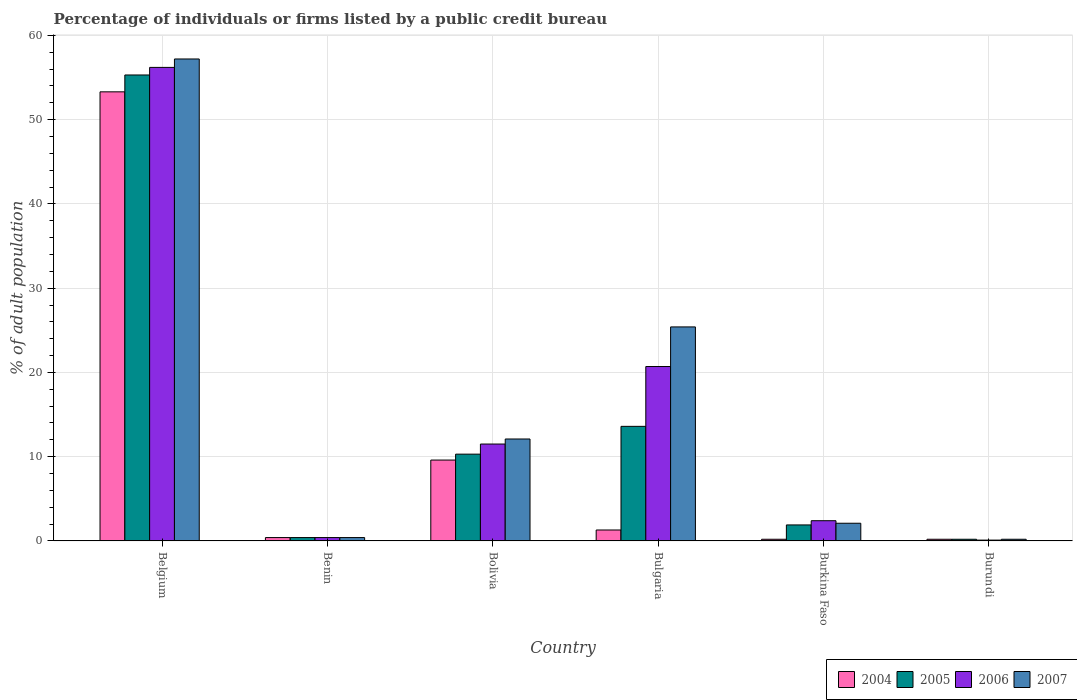How many groups of bars are there?
Offer a very short reply. 6. Are the number of bars on each tick of the X-axis equal?
Your answer should be compact. Yes. What is the label of the 2nd group of bars from the left?
Provide a succinct answer. Benin. Across all countries, what is the maximum percentage of population listed by a public credit bureau in 2004?
Your response must be concise. 53.3. In which country was the percentage of population listed by a public credit bureau in 2005 maximum?
Make the answer very short. Belgium. In which country was the percentage of population listed by a public credit bureau in 2005 minimum?
Ensure brevity in your answer.  Burundi. What is the total percentage of population listed by a public credit bureau in 2005 in the graph?
Your response must be concise. 81.7. What is the difference between the percentage of population listed by a public credit bureau in 2005 in Bulgaria and the percentage of population listed by a public credit bureau in 2006 in Bolivia?
Provide a succinct answer. 2.1. What is the average percentage of population listed by a public credit bureau in 2004 per country?
Keep it short and to the point. 10.83. What is the difference between the percentage of population listed by a public credit bureau of/in 2005 and percentage of population listed by a public credit bureau of/in 2007 in Bulgaria?
Your answer should be very brief. -11.8. In how many countries, is the percentage of population listed by a public credit bureau in 2005 greater than 4 %?
Your answer should be compact. 3. What is the ratio of the percentage of population listed by a public credit bureau in 2005 in Belgium to that in Bolivia?
Provide a succinct answer. 5.37. Is the percentage of population listed by a public credit bureau in 2004 in Burkina Faso less than that in Burundi?
Provide a short and direct response. No. Is the difference between the percentage of population listed by a public credit bureau in 2005 in Bolivia and Burkina Faso greater than the difference between the percentage of population listed by a public credit bureau in 2007 in Bolivia and Burkina Faso?
Offer a very short reply. No. What is the difference between the highest and the second highest percentage of population listed by a public credit bureau in 2005?
Offer a terse response. -3.3. What is the difference between the highest and the lowest percentage of population listed by a public credit bureau in 2006?
Your answer should be very brief. 56.1. In how many countries, is the percentage of population listed by a public credit bureau in 2004 greater than the average percentage of population listed by a public credit bureau in 2004 taken over all countries?
Make the answer very short. 1. Is the sum of the percentage of population listed by a public credit bureau in 2005 in Burkina Faso and Burundi greater than the maximum percentage of population listed by a public credit bureau in 2006 across all countries?
Keep it short and to the point. No. What does the 4th bar from the left in Burkina Faso represents?
Offer a very short reply. 2007. Is it the case that in every country, the sum of the percentage of population listed by a public credit bureau in 2006 and percentage of population listed by a public credit bureau in 2005 is greater than the percentage of population listed by a public credit bureau in 2007?
Make the answer very short. Yes. Are all the bars in the graph horizontal?
Make the answer very short. No. How many countries are there in the graph?
Provide a succinct answer. 6. What is the difference between two consecutive major ticks on the Y-axis?
Your answer should be compact. 10. Are the values on the major ticks of Y-axis written in scientific E-notation?
Ensure brevity in your answer.  No. Does the graph contain any zero values?
Ensure brevity in your answer.  No. What is the title of the graph?
Provide a succinct answer. Percentage of individuals or firms listed by a public credit bureau. Does "1979" appear as one of the legend labels in the graph?
Keep it short and to the point. No. What is the label or title of the Y-axis?
Your answer should be compact. % of adult population. What is the % of adult population of 2004 in Belgium?
Your answer should be very brief. 53.3. What is the % of adult population in 2005 in Belgium?
Offer a terse response. 55.3. What is the % of adult population of 2006 in Belgium?
Offer a terse response. 56.2. What is the % of adult population of 2007 in Belgium?
Provide a succinct answer. 57.2. What is the % of adult population of 2007 in Benin?
Offer a terse response. 0.4. What is the % of adult population of 2004 in Bolivia?
Your answer should be very brief. 9.6. What is the % of adult population of 2007 in Bolivia?
Your answer should be compact. 12.1. What is the % of adult population in 2006 in Bulgaria?
Your answer should be very brief. 20.7. What is the % of adult population in 2007 in Bulgaria?
Your answer should be very brief. 25.4. What is the % of adult population in 2006 in Burkina Faso?
Your answer should be compact. 2.4. What is the % of adult population in 2007 in Burkina Faso?
Offer a very short reply. 2.1. What is the % of adult population in 2004 in Burundi?
Your answer should be compact. 0.2. What is the % of adult population in 2006 in Burundi?
Provide a short and direct response. 0.1. Across all countries, what is the maximum % of adult population of 2004?
Give a very brief answer. 53.3. Across all countries, what is the maximum % of adult population in 2005?
Offer a very short reply. 55.3. Across all countries, what is the maximum % of adult population of 2006?
Offer a terse response. 56.2. Across all countries, what is the maximum % of adult population of 2007?
Provide a succinct answer. 57.2. Across all countries, what is the minimum % of adult population of 2004?
Make the answer very short. 0.2. What is the total % of adult population in 2004 in the graph?
Offer a terse response. 65. What is the total % of adult population of 2005 in the graph?
Your answer should be very brief. 81.7. What is the total % of adult population in 2006 in the graph?
Offer a very short reply. 91.3. What is the total % of adult population of 2007 in the graph?
Your answer should be compact. 97.4. What is the difference between the % of adult population of 2004 in Belgium and that in Benin?
Give a very brief answer. 52.9. What is the difference between the % of adult population of 2005 in Belgium and that in Benin?
Offer a terse response. 54.9. What is the difference between the % of adult population of 2006 in Belgium and that in Benin?
Give a very brief answer. 55.8. What is the difference between the % of adult population of 2007 in Belgium and that in Benin?
Provide a succinct answer. 56.8. What is the difference between the % of adult population of 2004 in Belgium and that in Bolivia?
Your answer should be very brief. 43.7. What is the difference between the % of adult population in 2006 in Belgium and that in Bolivia?
Give a very brief answer. 44.7. What is the difference between the % of adult population in 2007 in Belgium and that in Bolivia?
Give a very brief answer. 45.1. What is the difference between the % of adult population of 2004 in Belgium and that in Bulgaria?
Offer a terse response. 52. What is the difference between the % of adult population of 2005 in Belgium and that in Bulgaria?
Give a very brief answer. 41.7. What is the difference between the % of adult population of 2006 in Belgium and that in Bulgaria?
Provide a short and direct response. 35.5. What is the difference between the % of adult population of 2007 in Belgium and that in Bulgaria?
Your response must be concise. 31.8. What is the difference between the % of adult population of 2004 in Belgium and that in Burkina Faso?
Your answer should be compact. 53.1. What is the difference between the % of adult population in 2005 in Belgium and that in Burkina Faso?
Your answer should be compact. 53.4. What is the difference between the % of adult population of 2006 in Belgium and that in Burkina Faso?
Your answer should be very brief. 53.8. What is the difference between the % of adult population in 2007 in Belgium and that in Burkina Faso?
Your answer should be compact. 55.1. What is the difference between the % of adult population of 2004 in Belgium and that in Burundi?
Offer a terse response. 53.1. What is the difference between the % of adult population of 2005 in Belgium and that in Burundi?
Ensure brevity in your answer.  55.1. What is the difference between the % of adult population in 2006 in Belgium and that in Burundi?
Provide a succinct answer. 56.1. What is the difference between the % of adult population of 2007 in Belgium and that in Burundi?
Give a very brief answer. 57. What is the difference between the % of adult population in 2004 in Benin and that in Bolivia?
Provide a succinct answer. -9.2. What is the difference between the % of adult population of 2005 in Benin and that in Bolivia?
Your response must be concise. -9.9. What is the difference between the % of adult population of 2007 in Benin and that in Bolivia?
Offer a very short reply. -11.7. What is the difference between the % of adult population of 2004 in Benin and that in Bulgaria?
Provide a short and direct response. -0.9. What is the difference between the % of adult population of 2005 in Benin and that in Bulgaria?
Provide a succinct answer. -13.2. What is the difference between the % of adult population in 2006 in Benin and that in Bulgaria?
Make the answer very short. -20.3. What is the difference between the % of adult population of 2007 in Benin and that in Bulgaria?
Offer a very short reply. -25. What is the difference between the % of adult population in 2004 in Benin and that in Burkina Faso?
Ensure brevity in your answer.  0.2. What is the difference between the % of adult population in 2006 in Benin and that in Burkina Faso?
Provide a short and direct response. -2. What is the difference between the % of adult population in 2007 in Benin and that in Burkina Faso?
Your response must be concise. -1.7. What is the difference between the % of adult population in 2004 in Benin and that in Burundi?
Keep it short and to the point. 0.2. What is the difference between the % of adult population in 2007 in Benin and that in Burundi?
Keep it short and to the point. 0.2. What is the difference between the % of adult population of 2004 in Bolivia and that in Bulgaria?
Give a very brief answer. 8.3. What is the difference between the % of adult population in 2005 in Bolivia and that in Bulgaria?
Offer a terse response. -3.3. What is the difference between the % of adult population in 2006 in Bolivia and that in Bulgaria?
Provide a succinct answer. -9.2. What is the difference between the % of adult population of 2006 in Bolivia and that in Burkina Faso?
Provide a short and direct response. 9.1. What is the difference between the % of adult population of 2007 in Bolivia and that in Burkina Faso?
Provide a short and direct response. 10. What is the difference between the % of adult population of 2004 in Bolivia and that in Burundi?
Make the answer very short. 9.4. What is the difference between the % of adult population in 2006 in Bolivia and that in Burundi?
Keep it short and to the point. 11.4. What is the difference between the % of adult population of 2004 in Bulgaria and that in Burkina Faso?
Offer a terse response. 1.1. What is the difference between the % of adult population of 2005 in Bulgaria and that in Burkina Faso?
Give a very brief answer. 11.7. What is the difference between the % of adult population in 2007 in Bulgaria and that in Burkina Faso?
Keep it short and to the point. 23.3. What is the difference between the % of adult population of 2005 in Bulgaria and that in Burundi?
Your response must be concise. 13.4. What is the difference between the % of adult population in 2006 in Bulgaria and that in Burundi?
Your answer should be very brief. 20.6. What is the difference between the % of adult population of 2007 in Bulgaria and that in Burundi?
Your answer should be compact. 25.2. What is the difference between the % of adult population of 2006 in Burkina Faso and that in Burundi?
Make the answer very short. 2.3. What is the difference between the % of adult population of 2004 in Belgium and the % of adult population of 2005 in Benin?
Your response must be concise. 52.9. What is the difference between the % of adult population of 2004 in Belgium and the % of adult population of 2006 in Benin?
Provide a succinct answer. 52.9. What is the difference between the % of adult population in 2004 in Belgium and the % of adult population in 2007 in Benin?
Offer a very short reply. 52.9. What is the difference between the % of adult population of 2005 in Belgium and the % of adult population of 2006 in Benin?
Your answer should be very brief. 54.9. What is the difference between the % of adult population in 2005 in Belgium and the % of adult population in 2007 in Benin?
Your answer should be very brief. 54.9. What is the difference between the % of adult population of 2006 in Belgium and the % of adult population of 2007 in Benin?
Offer a terse response. 55.8. What is the difference between the % of adult population in 2004 in Belgium and the % of adult population in 2005 in Bolivia?
Make the answer very short. 43. What is the difference between the % of adult population in 2004 in Belgium and the % of adult population in 2006 in Bolivia?
Keep it short and to the point. 41.8. What is the difference between the % of adult population of 2004 in Belgium and the % of adult population of 2007 in Bolivia?
Provide a succinct answer. 41.2. What is the difference between the % of adult population of 2005 in Belgium and the % of adult population of 2006 in Bolivia?
Offer a very short reply. 43.8. What is the difference between the % of adult population of 2005 in Belgium and the % of adult population of 2007 in Bolivia?
Ensure brevity in your answer.  43.2. What is the difference between the % of adult population of 2006 in Belgium and the % of adult population of 2007 in Bolivia?
Keep it short and to the point. 44.1. What is the difference between the % of adult population of 2004 in Belgium and the % of adult population of 2005 in Bulgaria?
Your answer should be compact. 39.7. What is the difference between the % of adult population of 2004 in Belgium and the % of adult population of 2006 in Bulgaria?
Your answer should be very brief. 32.6. What is the difference between the % of adult population of 2004 in Belgium and the % of adult population of 2007 in Bulgaria?
Make the answer very short. 27.9. What is the difference between the % of adult population in 2005 in Belgium and the % of adult population in 2006 in Bulgaria?
Make the answer very short. 34.6. What is the difference between the % of adult population of 2005 in Belgium and the % of adult population of 2007 in Bulgaria?
Provide a short and direct response. 29.9. What is the difference between the % of adult population of 2006 in Belgium and the % of adult population of 2007 in Bulgaria?
Make the answer very short. 30.8. What is the difference between the % of adult population of 2004 in Belgium and the % of adult population of 2005 in Burkina Faso?
Offer a very short reply. 51.4. What is the difference between the % of adult population in 2004 in Belgium and the % of adult population in 2006 in Burkina Faso?
Your answer should be compact. 50.9. What is the difference between the % of adult population of 2004 in Belgium and the % of adult population of 2007 in Burkina Faso?
Your answer should be very brief. 51.2. What is the difference between the % of adult population of 2005 in Belgium and the % of adult population of 2006 in Burkina Faso?
Keep it short and to the point. 52.9. What is the difference between the % of adult population in 2005 in Belgium and the % of adult population in 2007 in Burkina Faso?
Ensure brevity in your answer.  53.2. What is the difference between the % of adult population of 2006 in Belgium and the % of adult population of 2007 in Burkina Faso?
Give a very brief answer. 54.1. What is the difference between the % of adult population in 2004 in Belgium and the % of adult population in 2005 in Burundi?
Make the answer very short. 53.1. What is the difference between the % of adult population in 2004 in Belgium and the % of adult population in 2006 in Burundi?
Ensure brevity in your answer.  53.2. What is the difference between the % of adult population in 2004 in Belgium and the % of adult population in 2007 in Burundi?
Ensure brevity in your answer.  53.1. What is the difference between the % of adult population of 2005 in Belgium and the % of adult population of 2006 in Burundi?
Your answer should be compact. 55.2. What is the difference between the % of adult population of 2005 in Belgium and the % of adult population of 2007 in Burundi?
Keep it short and to the point. 55.1. What is the difference between the % of adult population of 2006 in Belgium and the % of adult population of 2007 in Burundi?
Ensure brevity in your answer.  56. What is the difference between the % of adult population in 2004 in Benin and the % of adult population in 2006 in Bolivia?
Offer a terse response. -11.1. What is the difference between the % of adult population of 2004 in Benin and the % of adult population of 2007 in Bolivia?
Your answer should be compact. -11.7. What is the difference between the % of adult population in 2005 in Benin and the % of adult population in 2006 in Bolivia?
Give a very brief answer. -11.1. What is the difference between the % of adult population in 2005 in Benin and the % of adult population in 2007 in Bolivia?
Make the answer very short. -11.7. What is the difference between the % of adult population of 2004 in Benin and the % of adult population of 2005 in Bulgaria?
Ensure brevity in your answer.  -13.2. What is the difference between the % of adult population in 2004 in Benin and the % of adult population in 2006 in Bulgaria?
Make the answer very short. -20.3. What is the difference between the % of adult population in 2004 in Benin and the % of adult population in 2007 in Bulgaria?
Make the answer very short. -25. What is the difference between the % of adult population in 2005 in Benin and the % of adult population in 2006 in Bulgaria?
Offer a terse response. -20.3. What is the difference between the % of adult population of 2005 in Benin and the % of adult population of 2007 in Bulgaria?
Offer a very short reply. -25. What is the difference between the % of adult population of 2006 in Benin and the % of adult population of 2007 in Bulgaria?
Provide a short and direct response. -25. What is the difference between the % of adult population in 2004 in Benin and the % of adult population in 2006 in Burkina Faso?
Offer a terse response. -2. What is the difference between the % of adult population of 2004 in Benin and the % of adult population of 2007 in Burkina Faso?
Your response must be concise. -1.7. What is the difference between the % of adult population of 2005 in Benin and the % of adult population of 2006 in Burkina Faso?
Ensure brevity in your answer.  -2. What is the difference between the % of adult population in 2005 in Benin and the % of adult population in 2007 in Burkina Faso?
Make the answer very short. -1.7. What is the difference between the % of adult population in 2006 in Benin and the % of adult population in 2007 in Burkina Faso?
Your response must be concise. -1.7. What is the difference between the % of adult population of 2004 in Benin and the % of adult population of 2005 in Burundi?
Offer a terse response. 0.2. What is the difference between the % of adult population in 2005 in Benin and the % of adult population in 2006 in Burundi?
Offer a very short reply. 0.3. What is the difference between the % of adult population in 2004 in Bolivia and the % of adult population in 2007 in Bulgaria?
Provide a short and direct response. -15.8. What is the difference between the % of adult population in 2005 in Bolivia and the % of adult population in 2007 in Bulgaria?
Ensure brevity in your answer.  -15.1. What is the difference between the % of adult population in 2006 in Bolivia and the % of adult population in 2007 in Bulgaria?
Provide a short and direct response. -13.9. What is the difference between the % of adult population of 2004 in Bolivia and the % of adult population of 2005 in Burkina Faso?
Provide a succinct answer. 7.7. What is the difference between the % of adult population of 2004 in Bolivia and the % of adult population of 2007 in Burkina Faso?
Offer a very short reply. 7.5. What is the difference between the % of adult population in 2005 in Bolivia and the % of adult population in 2007 in Burkina Faso?
Provide a short and direct response. 8.2. What is the difference between the % of adult population in 2004 in Bolivia and the % of adult population in 2006 in Burundi?
Make the answer very short. 9.5. What is the difference between the % of adult population in 2004 in Bolivia and the % of adult population in 2007 in Burundi?
Make the answer very short. 9.4. What is the difference between the % of adult population in 2005 in Bolivia and the % of adult population in 2006 in Burundi?
Give a very brief answer. 10.2. What is the difference between the % of adult population of 2006 in Bolivia and the % of adult population of 2007 in Burundi?
Provide a short and direct response. 11.3. What is the difference between the % of adult population in 2004 in Bulgaria and the % of adult population in 2005 in Burkina Faso?
Offer a very short reply. -0.6. What is the difference between the % of adult population in 2004 in Bulgaria and the % of adult population in 2006 in Burkina Faso?
Provide a succinct answer. -1.1. What is the difference between the % of adult population of 2005 in Bulgaria and the % of adult population of 2007 in Burkina Faso?
Offer a terse response. 11.5. What is the difference between the % of adult population of 2004 in Bulgaria and the % of adult population of 2005 in Burundi?
Give a very brief answer. 1.1. What is the difference between the % of adult population in 2004 in Bulgaria and the % of adult population in 2006 in Burundi?
Offer a very short reply. 1.2. What is the difference between the % of adult population of 2005 in Burkina Faso and the % of adult population of 2007 in Burundi?
Offer a terse response. 1.7. What is the average % of adult population in 2004 per country?
Your answer should be compact. 10.83. What is the average % of adult population of 2005 per country?
Your answer should be compact. 13.62. What is the average % of adult population in 2006 per country?
Provide a succinct answer. 15.22. What is the average % of adult population of 2007 per country?
Provide a succinct answer. 16.23. What is the difference between the % of adult population of 2004 and % of adult population of 2005 in Belgium?
Provide a short and direct response. -2. What is the difference between the % of adult population of 2004 and % of adult population of 2006 in Belgium?
Ensure brevity in your answer.  -2.9. What is the difference between the % of adult population in 2004 and % of adult population in 2006 in Benin?
Offer a terse response. 0. What is the difference between the % of adult population in 2004 and % of adult population in 2005 in Bolivia?
Ensure brevity in your answer.  -0.7. What is the difference between the % of adult population of 2005 and % of adult population of 2007 in Bolivia?
Provide a short and direct response. -1.8. What is the difference between the % of adult population in 2006 and % of adult population in 2007 in Bolivia?
Your answer should be compact. -0.6. What is the difference between the % of adult population of 2004 and % of adult population of 2006 in Bulgaria?
Keep it short and to the point. -19.4. What is the difference between the % of adult population in 2004 and % of adult population in 2007 in Bulgaria?
Ensure brevity in your answer.  -24.1. What is the difference between the % of adult population in 2005 and % of adult population in 2006 in Bulgaria?
Your response must be concise. -7.1. What is the difference between the % of adult population of 2005 and % of adult population of 2007 in Bulgaria?
Your answer should be very brief. -11.8. What is the difference between the % of adult population in 2006 and % of adult population in 2007 in Bulgaria?
Your answer should be very brief. -4.7. What is the difference between the % of adult population of 2004 and % of adult population of 2007 in Burkina Faso?
Provide a succinct answer. -1.9. What is the difference between the % of adult population of 2005 and % of adult population of 2006 in Burkina Faso?
Your answer should be compact. -0.5. What is the difference between the % of adult population of 2004 and % of adult population of 2005 in Burundi?
Make the answer very short. 0. What is the difference between the % of adult population in 2004 and % of adult population in 2007 in Burundi?
Offer a very short reply. 0. What is the ratio of the % of adult population in 2004 in Belgium to that in Benin?
Make the answer very short. 133.25. What is the ratio of the % of adult population of 2005 in Belgium to that in Benin?
Your response must be concise. 138.25. What is the ratio of the % of adult population of 2006 in Belgium to that in Benin?
Provide a short and direct response. 140.5. What is the ratio of the % of adult population in 2007 in Belgium to that in Benin?
Your answer should be very brief. 143. What is the ratio of the % of adult population in 2004 in Belgium to that in Bolivia?
Give a very brief answer. 5.55. What is the ratio of the % of adult population in 2005 in Belgium to that in Bolivia?
Your answer should be very brief. 5.37. What is the ratio of the % of adult population in 2006 in Belgium to that in Bolivia?
Your answer should be compact. 4.89. What is the ratio of the % of adult population in 2007 in Belgium to that in Bolivia?
Your answer should be very brief. 4.73. What is the ratio of the % of adult population in 2005 in Belgium to that in Bulgaria?
Offer a terse response. 4.07. What is the ratio of the % of adult population in 2006 in Belgium to that in Bulgaria?
Give a very brief answer. 2.71. What is the ratio of the % of adult population in 2007 in Belgium to that in Bulgaria?
Offer a terse response. 2.25. What is the ratio of the % of adult population in 2004 in Belgium to that in Burkina Faso?
Your answer should be very brief. 266.5. What is the ratio of the % of adult population of 2005 in Belgium to that in Burkina Faso?
Your answer should be compact. 29.11. What is the ratio of the % of adult population in 2006 in Belgium to that in Burkina Faso?
Keep it short and to the point. 23.42. What is the ratio of the % of adult population of 2007 in Belgium to that in Burkina Faso?
Ensure brevity in your answer.  27.24. What is the ratio of the % of adult population in 2004 in Belgium to that in Burundi?
Offer a terse response. 266.5. What is the ratio of the % of adult population of 2005 in Belgium to that in Burundi?
Make the answer very short. 276.5. What is the ratio of the % of adult population in 2006 in Belgium to that in Burundi?
Ensure brevity in your answer.  562. What is the ratio of the % of adult population of 2007 in Belgium to that in Burundi?
Give a very brief answer. 286. What is the ratio of the % of adult population in 2004 in Benin to that in Bolivia?
Provide a succinct answer. 0.04. What is the ratio of the % of adult population in 2005 in Benin to that in Bolivia?
Your answer should be very brief. 0.04. What is the ratio of the % of adult population in 2006 in Benin to that in Bolivia?
Give a very brief answer. 0.03. What is the ratio of the % of adult population in 2007 in Benin to that in Bolivia?
Ensure brevity in your answer.  0.03. What is the ratio of the % of adult population of 2004 in Benin to that in Bulgaria?
Your answer should be compact. 0.31. What is the ratio of the % of adult population of 2005 in Benin to that in Bulgaria?
Your answer should be compact. 0.03. What is the ratio of the % of adult population of 2006 in Benin to that in Bulgaria?
Provide a short and direct response. 0.02. What is the ratio of the % of adult population of 2007 in Benin to that in Bulgaria?
Ensure brevity in your answer.  0.02. What is the ratio of the % of adult population in 2005 in Benin to that in Burkina Faso?
Your answer should be compact. 0.21. What is the ratio of the % of adult population in 2006 in Benin to that in Burkina Faso?
Give a very brief answer. 0.17. What is the ratio of the % of adult population in 2007 in Benin to that in Burkina Faso?
Offer a terse response. 0.19. What is the ratio of the % of adult population of 2006 in Benin to that in Burundi?
Give a very brief answer. 4. What is the ratio of the % of adult population in 2007 in Benin to that in Burundi?
Your answer should be compact. 2. What is the ratio of the % of adult population of 2004 in Bolivia to that in Bulgaria?
Ensure brevity in your answer.  7.38. What is the ratio of the % of adult population of 2005 in Bolivia to that in Bulgaria?
Your response must be concise. 0.76. What is the ratio of the % of adult population in 2006 in Bolivia to that in Bulgaria?
Provide a short and direct response. 0.56. What is the ratio of the % of adult population of 2007 in Bolivia to that in Bulgaria?
Give a very brief answer. 0.48. What is the ratio of the % of adult population in 2005 in Bolivia to that in Burkina Faso?
Provide a succinct answer. 5.42. What is the ratio of the % of adult population in 2006 in Bolivia to that in Burkina Faso?
Your answer should be compact. 4.79. What is the ratio of the % of adult population in 2007 in Bolivia to that in Burkina Faso?
Keep it short and to the point. 5.76. What is the ratio of the % of adult population of 2005 in Bolivia to that in Burundi?
Provide a succinct answer. 51.5. What is the ratio of the % of adult population in 2006 in Bolivia to that in Burundi?
Keep it short and to the point. 115. What is the ratio of the % of adult population of 2007 in Bolivia to that in Burundi?
Ensure brevity in your answer.  60.5. What is the ratio of the % of adult population in 2005 in Bulgaria to that in Burkina Faso?
Your answer should be compact. 7.16. What is the ratio of the % of adult population of 2006 in Bulgaria to that in Burkina Faso?
Keep it short and to the point. 8.62. What is the ratio of the % of adult population of 2007 in Bulgaria to that in Burkina Faso?
Offer a terse response. 12.1. What is the ratio of the % of adult population of 2005 in Bulgaria to that in Burundi?
Provide a succinct answer. 68. What is the ratio of the % of adult population in 2006 in Bulgaria to that in Burundi?
Your answer should be compact. 207. What is the ratio of the % of adult population of 2007 in Bulgaria to that in Burundi?
Offer a terse response. 127. What is the difference between the highest and the second highest % of adult population of 2004?
Ensure brevity in your answer.  43.7. What is the difference between the highest and the second highest % of adult population in 2005?
Ensure brevity in your answer.  41.7. What is the difference between the highest and the second highest % of adult population in 2006?
Provide a short and direct response. 35.5. What is the difference between the highest and the second highest % of adult population in 2007?
Offer a very short reply. 31.8. What is the difference between the highest and the lowest % of adult population of 2004?
Ensure brevity in your answer.  53.1. What is the difference between the highest and the lowest % of adult population of 2005?
Your response must be concise. 55.1. What is the difference between the highest and the lowest % of adult population of 2006?
Make the answer very short. 56.1. What is the difference between the highest and the lowest % of adult population of 2007?
Ensure brevity in your answer.  57. 